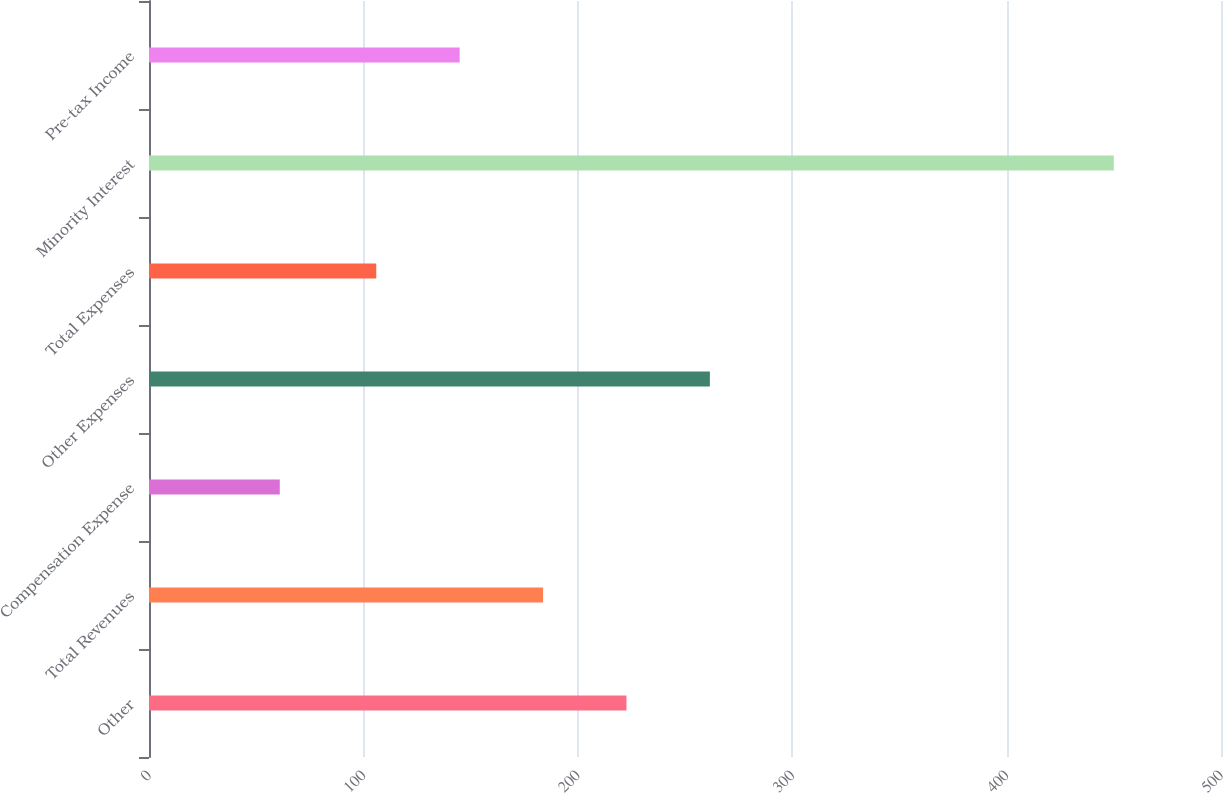Convert chart to OTSL. <chart><loc_0><loc_0><loc_500><loc_500><bar_chart><fcel>Other<fcel>Total Revenues<fcel>Compensation Expense<fcel>Other Expenses<fcel>Total Expenses<fcel>Minority Interest<fcel>Pre-tax Income<nl><fcel>222.7<fcel>183.8<fcel>61<fcel>261.6<fcel>106<fcel>450<fcel>144.9<nl></chart> 